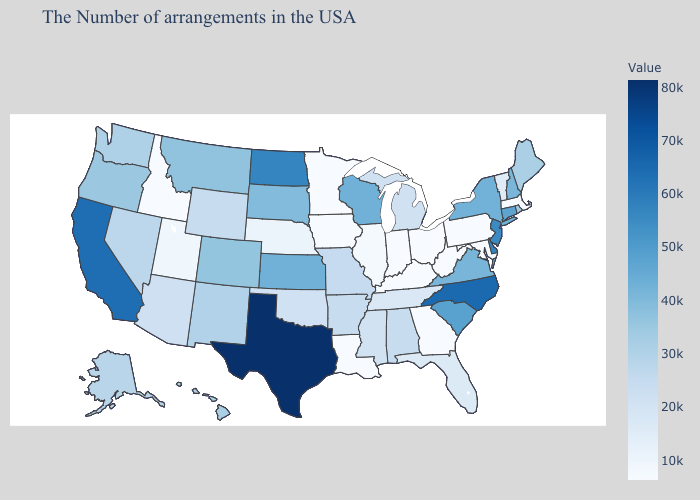Which states hav the highest value in the West?
Quick response, please. California. Does Indiana have the lowest value in the MidWest?
Write a very short answer. Yes. Is the legend a continuous bar?
Write a very short answer. Yes. Does North Carolina have the lowest value in the USA?
Be succinct. No. Does the map have missing data?
Quick response, please. No. Does Iowa have the lowest value in the USA?
Concise answer only. Yes. Among the states that border Washington , which have the lowest value?
Keep it brief. Idaho. 